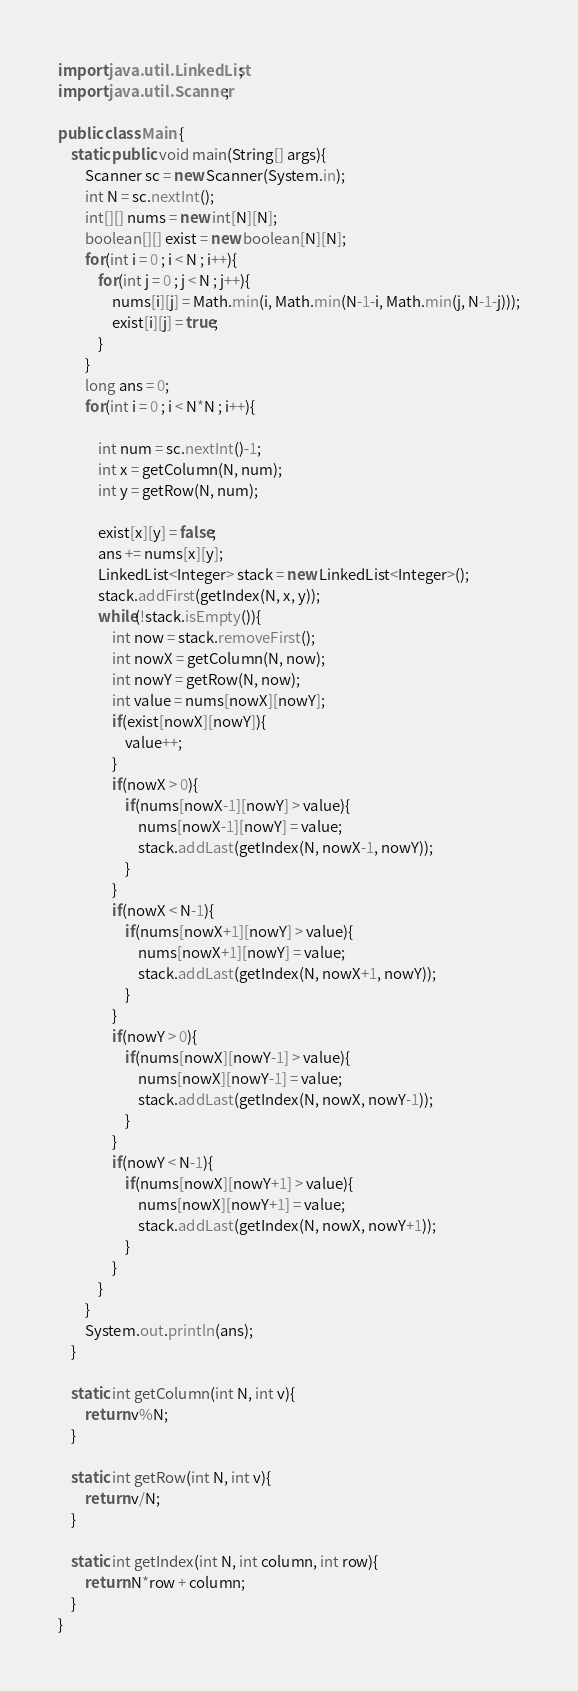<code> <loc_0><loc_0><loc_500><loc_500><_Java_>import java.util.LinkedList;
import java.util.Scanner;

public class Main {
    static public void main(String[] args){
        Scanner sc = new Scanner(System.in);
        int N = sc.nextInt();
        int[][] nums = new int[N][N];
        boolean[][] exist = new boolean[N][N];
        for(int i = 0 ; i < N ; i++){
            for(int j = 0 ; j < N ; j++){
                nums[i][j] = Math.min(i, Math.min(N-1-i, Math.min(j, N-1-j)));
                exist[i][j] = true;
            }
        }
        long ans = 0;
        for(int i = 0 ; i < N*N ; i++){

            int num = sc.nextInt()-1;
            int x = getColumn(N, num);
            int y = getRow(N, num);
            
            exist[x][y] = false;
            ans += nums[x][y];
            LinkedList<Integer> stack = new LinkedList<Integer>();
            stack.addFirst(getIndex(N, x, y));
            while(!stack.isEmpty()){
                int now = stack.removeFirst();
                int nowX = getColumn(N, now);
                int nowY = getRow(N, now);
                int value = nums[nowX][nowY];
                if(exist[nowX][nowY]){
                    value++;
                }
                if(nowX > 0){
                    if(nums[nowX-1][nowY] > value){
                        nums[nowX-1][nowY] = value;
                        stack.addLast(getIndex(N, nowX-1, nowY));
                    }
                }
                if(nowX < N-1){
                    if(nums[nowX+1][nowY] > value){
                        nums[nowX+1][nowY] = value;
                        stack.addLast(getIndex(N, nowX+1, nowY));
                    }
                }
                if(nowY > 0){
                    if(nums[nowX][nowY-1] > value){
                        nums[nowX][nowY-1] = value;
                        stack.addLast(getIndex(N, nowX, nowY-1));
                    }
                }
                if(nowY < N-1){
                    if(nums[nowX][nowY+1] > value){
                        nums[nowX][nowY+1] = value;
                        stack.addLast(getIndex(N, nowX, nowY+1));
                    }
                }
            }
        }
        System.out.println(ans);
    }

    static int getColumn(int N, int v){
        return v%N;
    }

    static int getRow(int N, int v){
        return v/N;
    }

    static int getIndex(int N, int column, int row){
        return N*row + column;
    }
}
</code> 